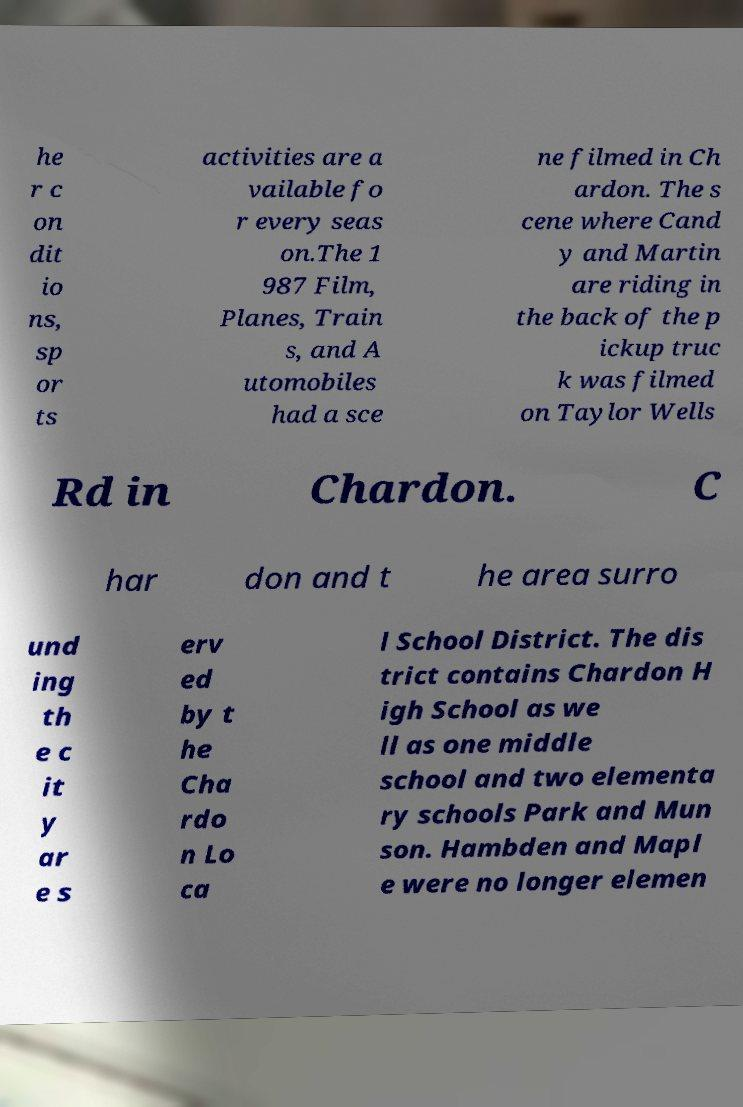Could you assist in decoding the text presented in this image and type it out clearly? he r c on dit io ns, sp or ts activities are a vailable fo r every seas on.The 1 987 Film, Planes, Train s, and A utomobiles had a sce ne filmed in Ch ardon. The s cene where Cand y and Martin are riding in the back of the p ickup truc k was filmed on Taylor Wells Rd in Chardon. C har don and t he area surro und ing th e c it y ar e s erv ed by t he Cha rdo n Lo ca l School District. The dis trict contains Chardon H igh School as we ll as one middle school and two elementa ry schools Park and Mun son. Hambden and Mapl e were no longer elemen 